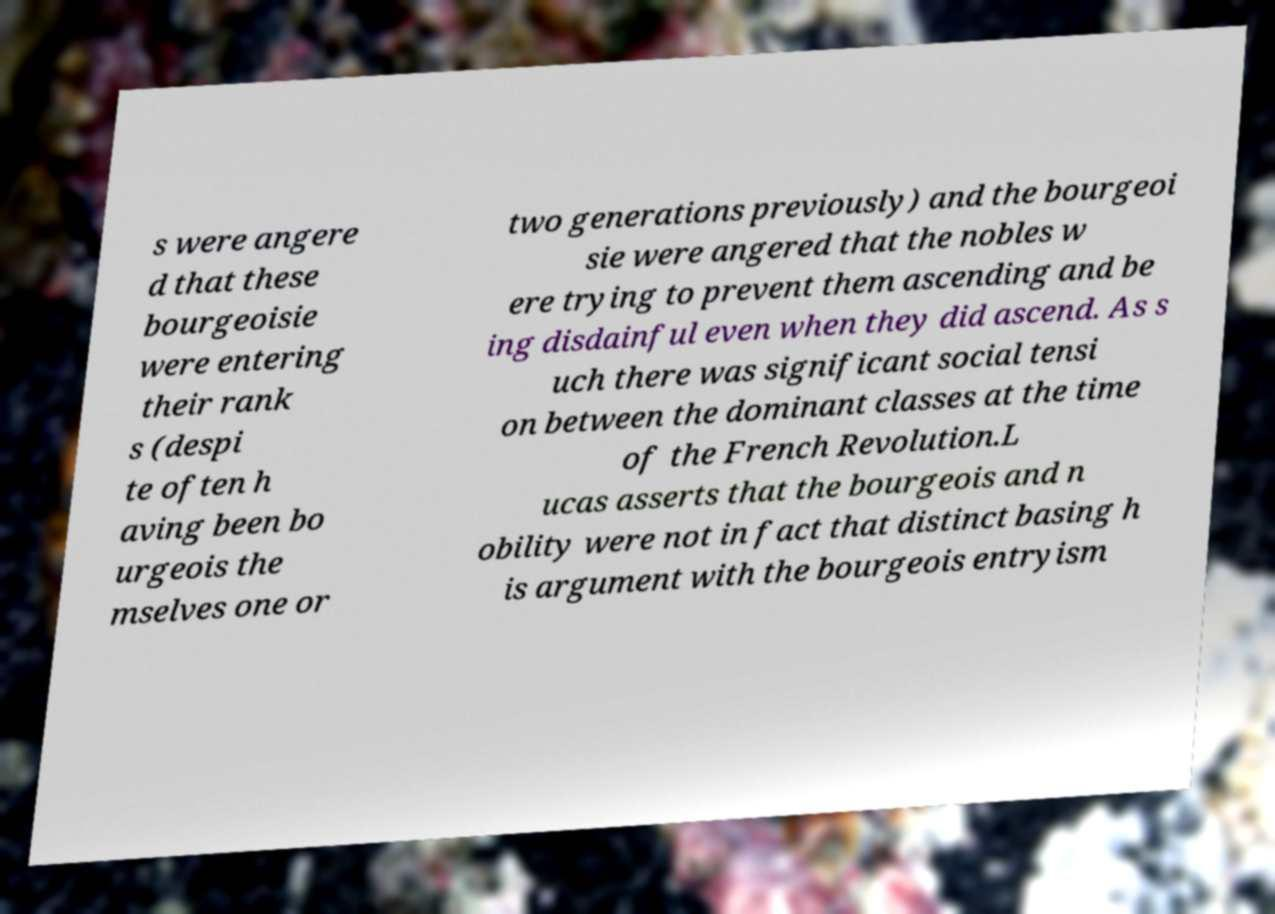Could you assist in decoding the text presented in this image and type it out clearly? s were angere d that these bourgeoisie were entering their rank s (despi te often h aving been bo urgeois the mselves one or two generations previously) and the bourgeoi sie were angered that the nobles w ere trying to prevent them ascending and be ing disdainful even when they did ascend. As s uch there was significant social tensi on between the dominant classes at the time of the French Revolution.L ucas asserts that the bourgeois and n obility were not in fact that distinct basing h is argument with the bourgeois entryism 